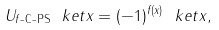<formula> <loc_0><loc_0><loc_500><loc_500>U _ { \text {$f$-C-PS} } \ k e t { x } = ( - 1 ) ^ { f ( x ) } \ k e t { x } ,</formula> 